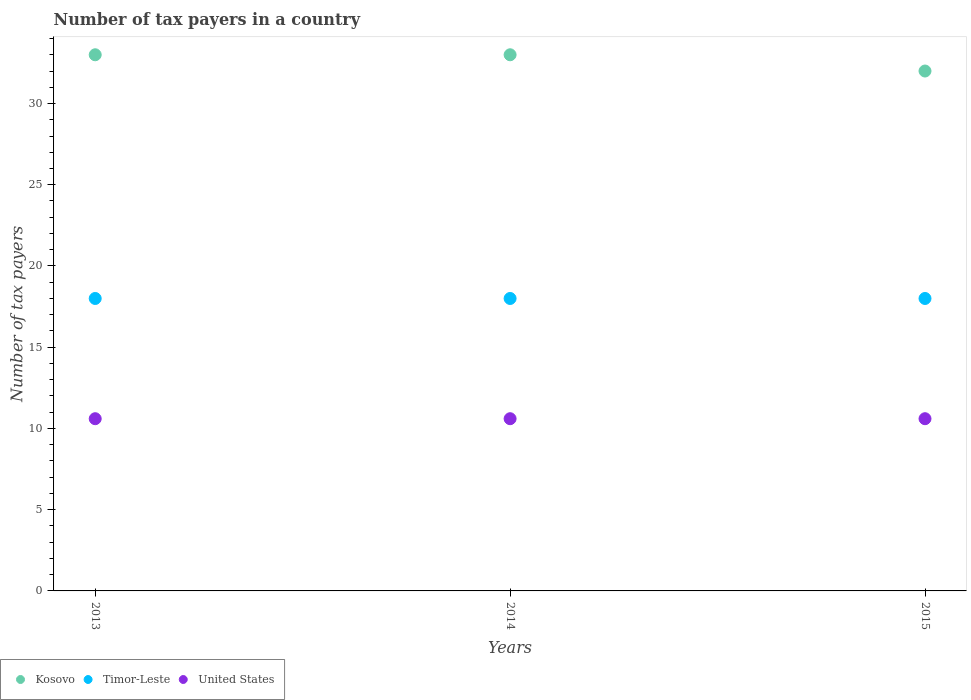What is the number of tax payers in in Kosovo in 2015?
Ensure brevity in your answer.  32. Across all years, what is the minimum number of tax payers in in United States?
Make the answer very short. 10.6. In which year was the number of tax payers in in Kosovo maximum?
Offer a terse response. 2013. What is the total number of tax payers in in Kosovo in the graph?
Offer a very short reply. 98. What is the difference between the number of tax payers in in Kosovo in 2015 and the number of tax payers in in United States in 2013?
Give a very brief answer. 21.4. What is the average number of tax payers in in Kosovo per year?
Your response must be concise. 32.67. In the year 2014, what is the difference between the number of tax payers in in Timor-Leste and number of tax payers in in Kosovo?
Your answer should be compact. -15. Is the difference between the number of tax payers in in Timor-Leste in 2014 and 2015 greater than the difference between the number of tax payers in in Kosovo in 2014 and 2015?
Offer a very short reply. No. What is the difference between the highest and the lowest number of tax payers in in United States?
Provide a succinct answer. 0. Is the sum of the number of tax payers in in United States in 2013 and 2015 greater than the maximum number of tax payers in in Kosovo across all years?
Ensure brevity in your answer.  No. Does the number of tax payers in in Timor-Leste monotonically increase over the years?
Your response must be concise. No. How many years are there in the graph?
Your response must be concise. 3. What is the difference between two consecutive major ticks on the Y-axis?
Your answer should be compact. 5. Does the graph contain any zero values?
Your response must be concise. No. Where does the legend appear in the graph?
Give a very brief answer. Bottom left. What is the title of the graph?
Keep it short and to the point. Number of tax payers in a country. Does "Comoros" appear as one of the legend labels in the graph?
Give a very brief answer. No. What is the label or title of the Y-axis?
Your answer should be compact. Number of tax payers. What is the Number of tax payers of Kosovo in 2013?
Keep it short and to the point. 33. What is the Number of tax payers of Timor-Leste in 2013?
Provide a succinct answer. 18. What is the Number of tax payers of United States in 2013?
Your answer should be very brief. 10.6. What is the Number of tax payers of Timor-Leste in 2014?
Your answer should be compact. 18. What is the Number of tax payers in United States in 2014?
Offer a terse response. 10.6. What is the Number of tax payers in Kosovo in 2015?
Your response must be concise. 32. What is the Number of tax payers of United States in 2015?
Offer a terse response. 10.6. Across all years, what is the maximum Number of tax payers in Kosovo?
Your response must be concise. 33. Across all years, what is the maximum Number of tax payers in Timor-Leste?
Your answer should be very brief. 18. Across all years, what is the maximum Number of tax payers of United States?
Ensure brevity in your answer.  10.6. Across all years, what is the minimum Number of tax payers in Kosovo?
Provide a succinct answer. 32. Across all years, what is the minimum Number of tax payers of United States?
Offer a terse response. 10.6. What is the total Number of tax payers in Kosovo in the graph?
Provide a succinct answer. 98. What is the total Number of tax payers of United States in the graph?
Provide a succinct answer. 31.8. What is the difference between the Number of tax payers in Timor-Leste in 2013 and that in 2014?
Give a very brief answer. 0. What is the difference between the Number of tax payers in Kosovo in 2013 and that in 2015?
Give a very brief answer. 1. What is the difference between the Number of tax payers in Timor-Leste in 2013 and that in 2015?
Offer a very short reply. 0. What is the difference between the Number of tax payers of Kosovo in 2014 and that in 2015?
Give a very brief answer. 1. What is the difference between the Number of tax payers of Timor-Leste in 2014 and that in 2015?
Provide a succinct answer. 0. What is the difference between the Number of tax payers in Kosovo in 2013 and the Number of tax payers in Timor-Leste in 2014?
Your answer should be very brief. 15. What is the difference between the Number of tax payers in Kosovo in 2013 and the Number of tax payers in United States in 2014?
Give a very brief answer. 22.4. What is the difference between the Number of tax payers of Timor-Leste in 2013 and the Number of tax payers of United States in 2014?
Offer a terse response. 7.4. What is the difference between the Number of tax payers in Kosovo in 2013 and the Number of tax payers in Timor-Leste in 2015?
Your response must be concise. 15. What is the difference between the Number of tax payers in Kosovo in 2013 and the Number of tax payers in United States in 2015?
Offer a terse response. 22.4. What is the difference between the Number of tax payers of Kosovo in 2014 and the Number of tax payers of Timor-Leste in 2015?
Make the answer very short. 15. What is the difference between the Number of tax payers of Kosovo in 2014 and the Number of tax payers of United States in 2015?
Offer a very short reply. 22.4. What is the average Number of tax payers in Kosovo per year?
Your answer should be very brief. 32.67. In the year 2013, what is the difference between the Number of tax payers in Kosovo and Number of tax payers in United States?
Provide a succinct answer. 22.4. In the year 2014, what is the difference between the Number of tax payers of Kosovo and Number of tax payers of United States?
Your response must be concise. 22.4. In the year 2015, what is the difference between the Number of tax payers of Kosovo and Number of tax payers of United States?
Offer a terse response. 21.4. In the year 2015, what is the difference between the Number of tax payers of Timor-Leste and Number of tax payers of United States?
Offer a terse response. 7.4. What is the ratio of the Number of tax payers of Kosovo in 2013 to that in 2014?
Offer a very short reply. 1. What is the ratio of the Number of tax payers of Timor-Leste in 2013 to that in 2014?
Keep it short and to the point. 1. What is the ratio of the Number of tax payers in United States in 2013 to that in 2014?
Provide a short and direct response. 1. What is the ratio of the Number of tax payers in Kosovo in 2013 to that in 2015?
Offer a terse response. 1.03. What is the ratio of the Number of tax payers in Kosovo in 2014 to that in 2015?
Offer a terse response. 1.03. What is the ratio of the Number of tax payers in Timor-Leste in 2014 to that in 2015?
Offer a terse response. 1. What is the ratio of the Number of tax payers in United States in 2014 to that in 2015?
Give a very brief answer. 1. What is the difference between the highest and the second highest Number of tax payers of Timor-Leste?
Offer a terse response. 0. What is the difference between the highest and the lowest Number of tax payers of Kosovo?
Your answer should be very brief. 1. What is the difference between the highest and the lowest Number of tax payers in Timor-Leste?
Provide a succinct answer. 0. 